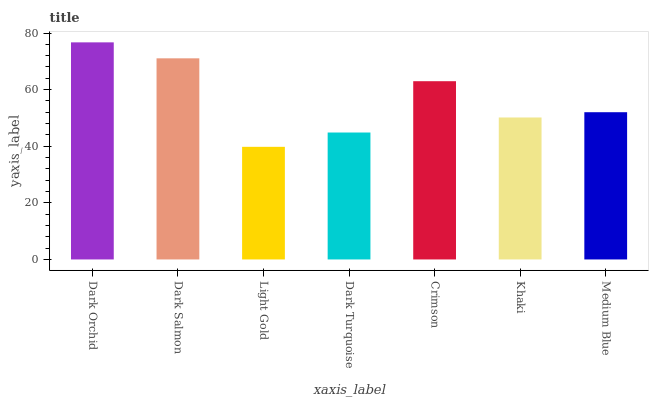Is Light Gold the minimum?
Answer yes or no. Yes. Is Dark Orchid the maximum?
Answer yes or no. Yes. Is Dark Salmon the minimum?
Answer yes or no. No. Is Dark Salmon the maximum?
Answer yes or no. No. Is Dark Orchid greater than Dark Salmon?
Answer yes or no. Yes. Is Dark Salmon less than Dark Orchid?
Answer yes or no. Yes. Is Dark Salmon greater than Dark Orchid?
Answer yes or no. No. Is Dark Orchid less than Dark Salmon?
Answer yes or no. No. Is Medium Blue the high median?
Answer yes or no. Yes. Is Medium Blue the low median?
Answer yes or no. Yes. Is Light Gold the high median?
Answer yes or no. No. Is Dark Orchid the low median?
Answer yes or no. No. 